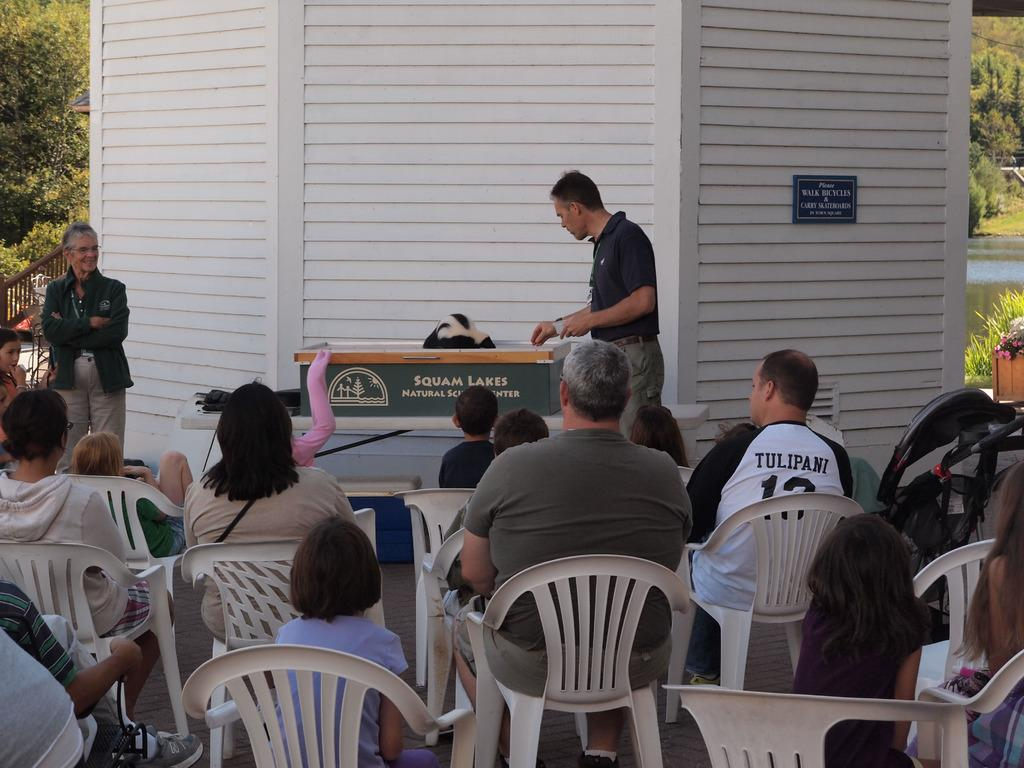<image>
Summarize the visual content of the image. Person giving a speech in front of a podium that says Squam Lakes. 